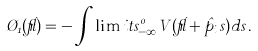Convert formula to latex. <formula><loc_0><loc_0><loc_500><loc_500>\chi _ { 1 } ( \vec { r } ) = - \int \lim i t s _ { - \infty } ^ { 0 } V ( \vec { r } + \hat { p } _ { i } s ) d s \, .</formula> 